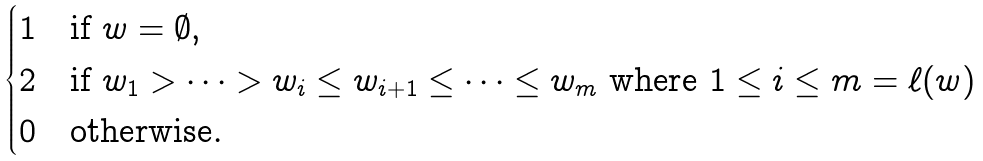<formula> <loc_0><loc_0><loc_500><loc_500>\begin{cases} 1 & \text {if } w = \emptyset , \\ 2 & \text {if } w _ { 1 } > \dots > w _ { i } \leq w _ { i + 1 } \leq \dots \leq w _ { m } \text { where $1 \leq i \leq m=\ell(w)$} \\ 0 & \text {otherwise} . \end{cases}</formula> 